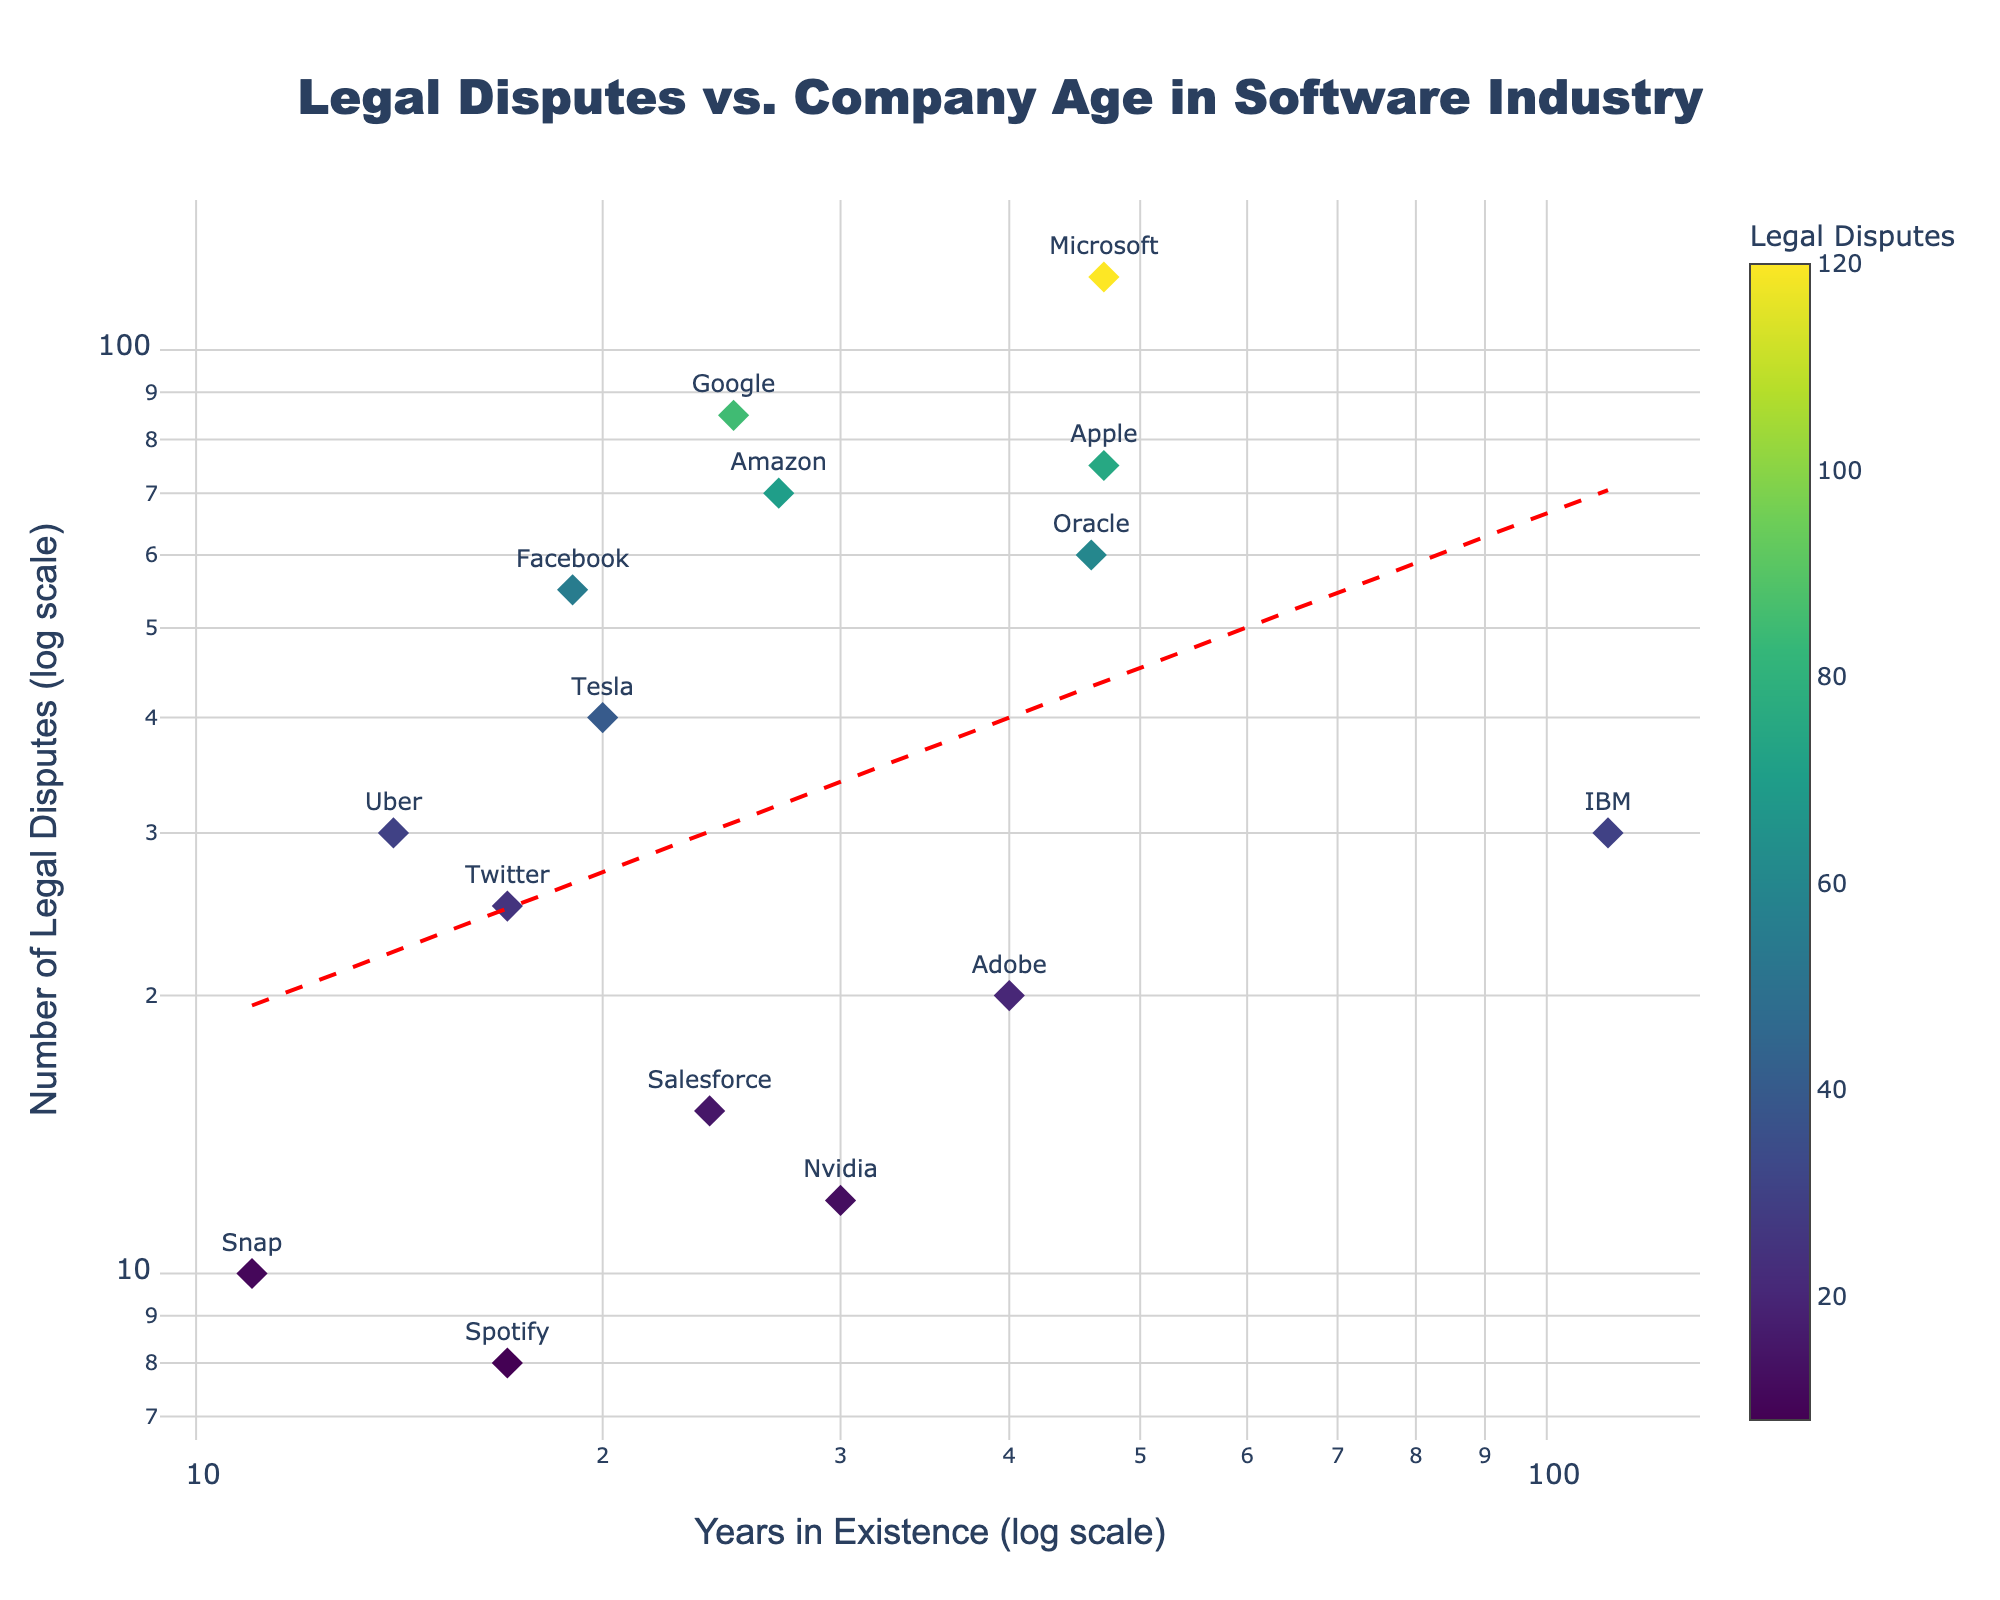What's the title of the figure? The title can usually be found at the top center of the figure. In this case, it is written in a large, bold Arial Black font for visibility.
Answer: Legal Disputes vs. Company Age in Software Industry How many companies have more than 50 legal disputes? By inspecting the y-axis values and counting the data points that fall above the y=50 mark, we see markers for Microsoft, Google, Apple, Facebook, and Amazon.
Answer: 5 Which company has existed for the shortest amount of time? The x-axis represents the years in existence. By identifying the point with the lowest x-value, we see that Snap has the least number of years in existence.
Answer: Snap What's the trend in the relationship between the years in existence and the number of legal disputes? The trend is indicated by the red dashed line. It shows that as the number of years in existence increases, the number of legal disputes generally increases.
Answer: The number of legal disputes increases with the company's age Are there any companies with fewer than 10 legal disputes? We need to identify the data points with y-values less than 10. By checking, we see Snap and Spotify fit this criterion.
Answer: 2 Which company has been in existence the longest and how many legal disputes do they have? Look for the data point farthest to the right on the x-axis. IBM has existed for the longest time (111 years) and has 30 legal disputes.
Answer: IBM, 30 Is there any company that has been in existence for over 100 years? We locate the data points with x-axis values exceeding 100. IBM is the only company fitting this condition.
Answer: Yes, IBM What is the average number of legal disputes for companies in existence for 20 years or less? Identify companies with ≤20 years. These are Tesla, Facebook, Snap, Spotify, Twitter, and Uber. Sum their disputes (40 + 55 + 10 + 8 + 25 + 30 = 168) and divide by the number of companies (6).
Answer: 28 Which company has the highest number of legal disputes and how many? Look for the highest data point on the y-axis. Microsoft has the most, with 120 legal disputes.
Answer: Microsoft, 120 Do newer companies (less than 30 years in existence) tend to have fewer legal disputes compared to older companies? Compare the data points of newer companies (≤30 years) against older ones (>30 years). Newer companies generally have fewer disputes indicated by their mostly lower positions on the y-axis, but some exceptions like Amazon and Facebook exist.
Answer: Generally yes, but there are exceptions 